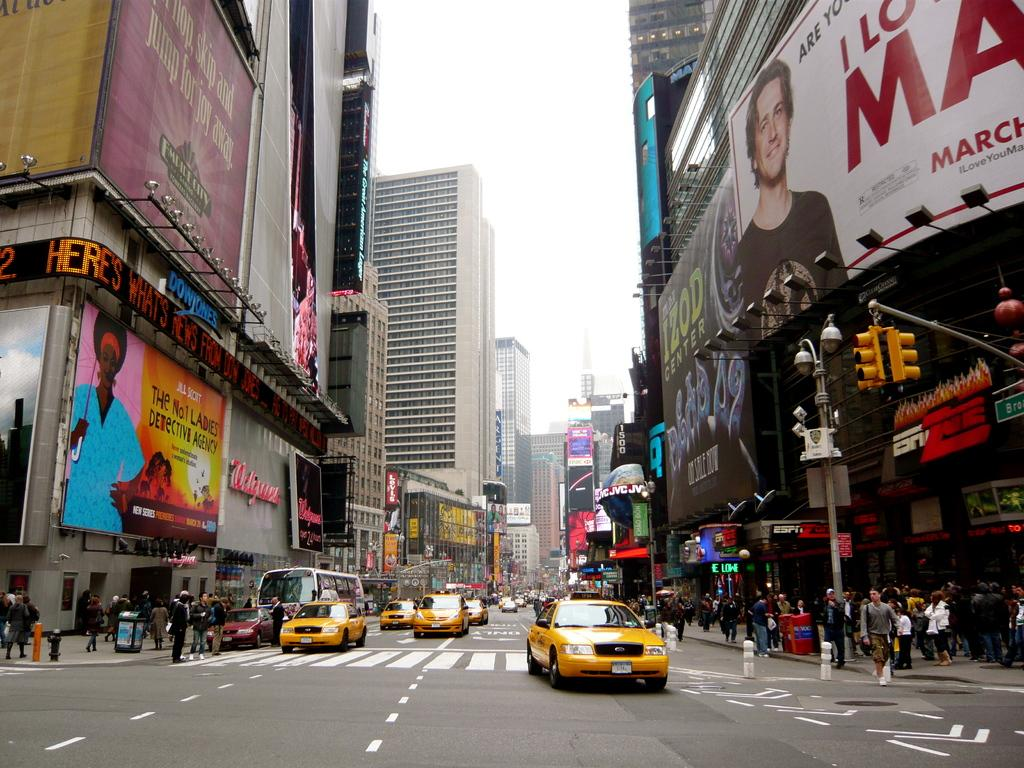What can be seen on the road in the image? There are vehicles on the road in the image. What structures are visible in the image? There are buildings visible in the image. What additional elements can be seen in the image? Banners and a traffic signal light are present in the image. What is the purpose of the pole in the image? The pole is likely used to support the traffic signal light or other signage. What are the people in the image doing? A group of people are walking on footpaths in the image. What can be seen in the background of the image? The sky is visible in the background of the image. What type of lunch is being served in the image? There is no mention of lunch or any food in the image. Can you see any planes flying in the sky in the image? There is no mention of planes or any aerial objects in the image. 